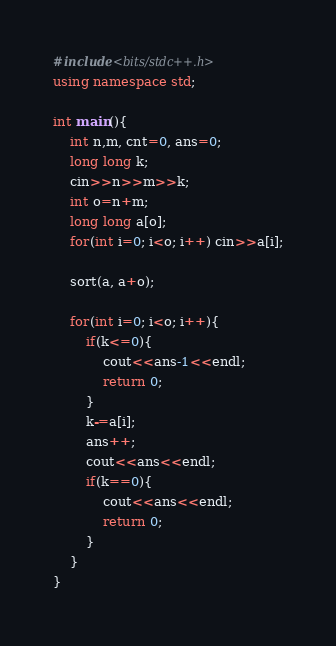<code> <loc_0><loc_0><loc_500><loc_500><_C++_>#include<bits/stdc++.h>
using namespace std;

int main(){
    int n,m, cnt=0, ans=0;
    long long k;
    cin>>n>>m>>k;
    int o=n+m;
    long long a[o];
    for(int i=0; i<o; i++) cin>>a[i];

    sort(a, a+o);

    for(int i=0; i<o; i++){
        if(k<=0){
            cout<<ans-1<<endl;
            return 0;
        }
        k-=a[i];
        ans++;
        cout<<ans<<endl;
        if(k==0){
            cout<<ans<<endl;
            return 0;
        }
    }
}
</code> 